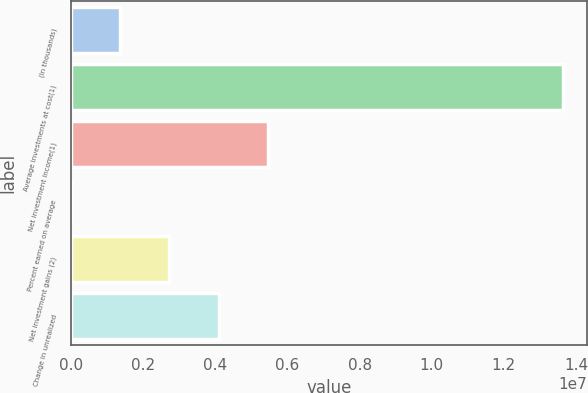<chart> <loc_0><loc_0><loc_500><loc_500><bar_chart><fcel>(In thousands)<fcel>Average investments at cost(1)<fcel>Net investment income(1)<fcel>Percent earned on average<fcel>Net investment gains (2)<fcel>Change in unrealized<nl><fcel>1.36316e+06<fcel>1.36316e+07<fcel>5.45262e+06<fcel>3.9<fcel>2.72631e+06<fcel>4.08947e+06<nl></chart> 